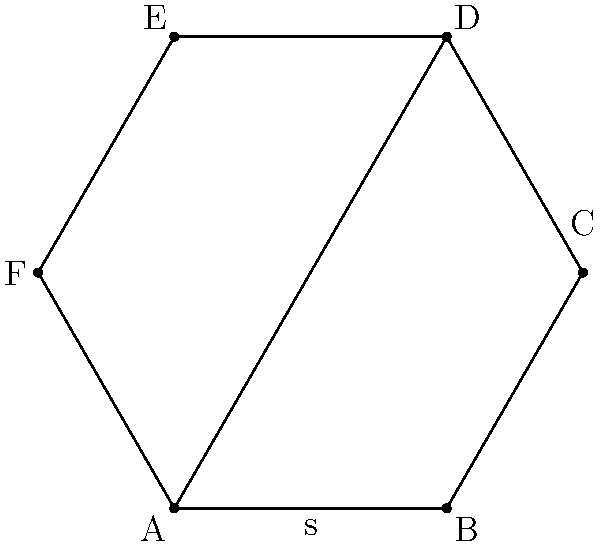As part of developing a new workplace safety policy, you need to calculate the area of a hexagonal emergency assembly point. The regular hexagon has a side length of 2 meters. Using trigonometric functions, calculate the area of this hexagon to determine if it meets the minimum space requirements for the number of employees. To find the area of a regular hexagon using trigonometric functions, we can follow these steps:

1) First, we need to recognize that a regular hexagon can be divided into six equilateral triangles.

2) The area of the hexagon will be six times the area of one of these triangles.

3) For an equilateral triangle with side length $s$, the area is given by:

   $A_{triangle} = \frac{\sqrt{3}}{4}s^2$

4) In this case, $s = 2$ meters.

5) Substituting this into our formula:

   $A_{triangle} = \frac{\sqrt{3}}{4}(2)^2 = \sqrt{3}$ square meters

6) The area of the hexagon is six times this:

   $A_{hexagon} = 6 \cdot A_{triangle} = 6\sqrt{3}$ square meters

7) If we want to express this as a decimal, we can calculate:

   $6\sqrt{3} \approx 10.3923$ square meters

Therefore, the area of the hexagonal emergency assembly point is $6\sqrt{3}$ or approximately 10.3923 square meters.
Answer: $6\sqrt{3}$ m² (or approximately 10.3923 m²) 